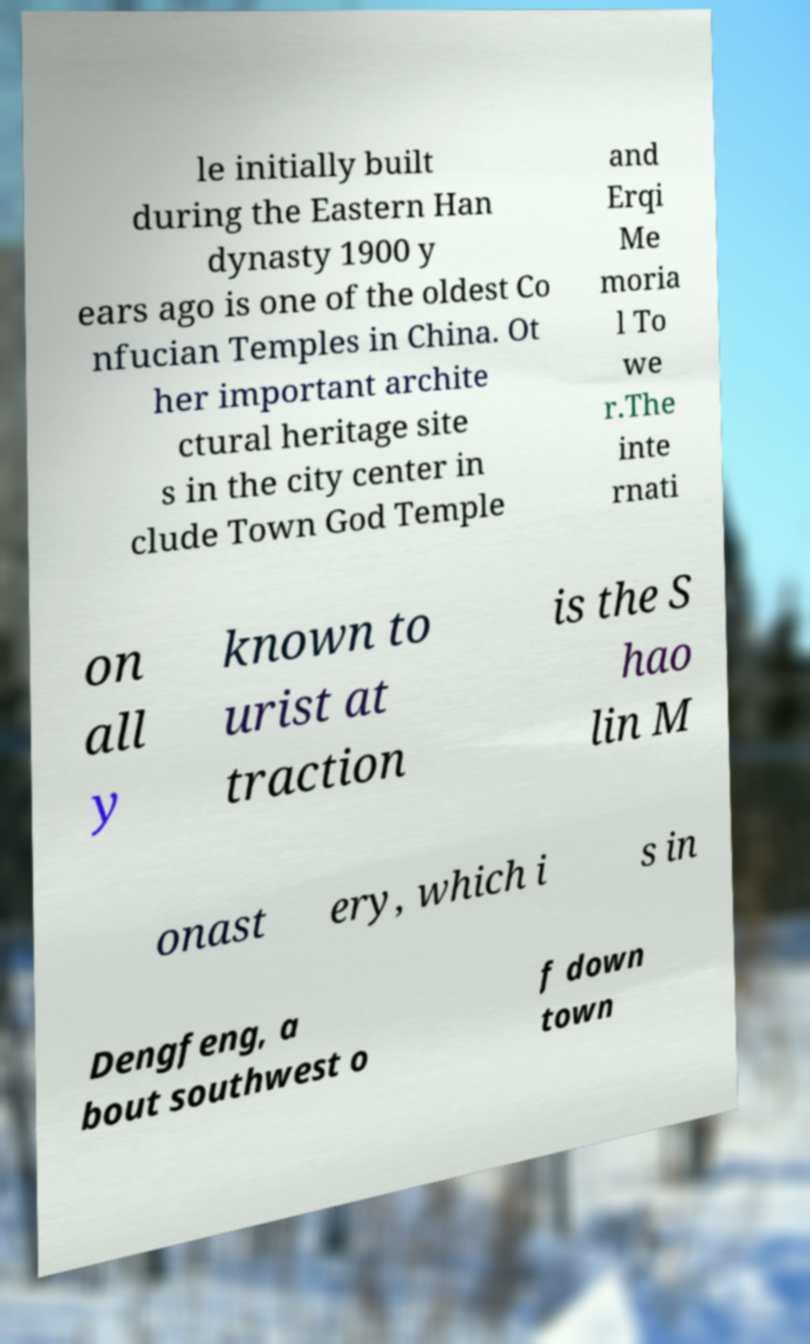What messages or text are displayed in this image? I need them in a readable, typed format. le initially built during the Eastern Han dynasty 1900 y ears ago is one of the oldest Co nfucian Temples in China. Ot her important archite ctural heritage site s in the city center in clude Town God Temple and Erqi Me moria l To we r.The inte rnati on all y known to urist at traction is the S hao lin M onast ery, which i s in Dengfeng, a bout southwest o f down town 